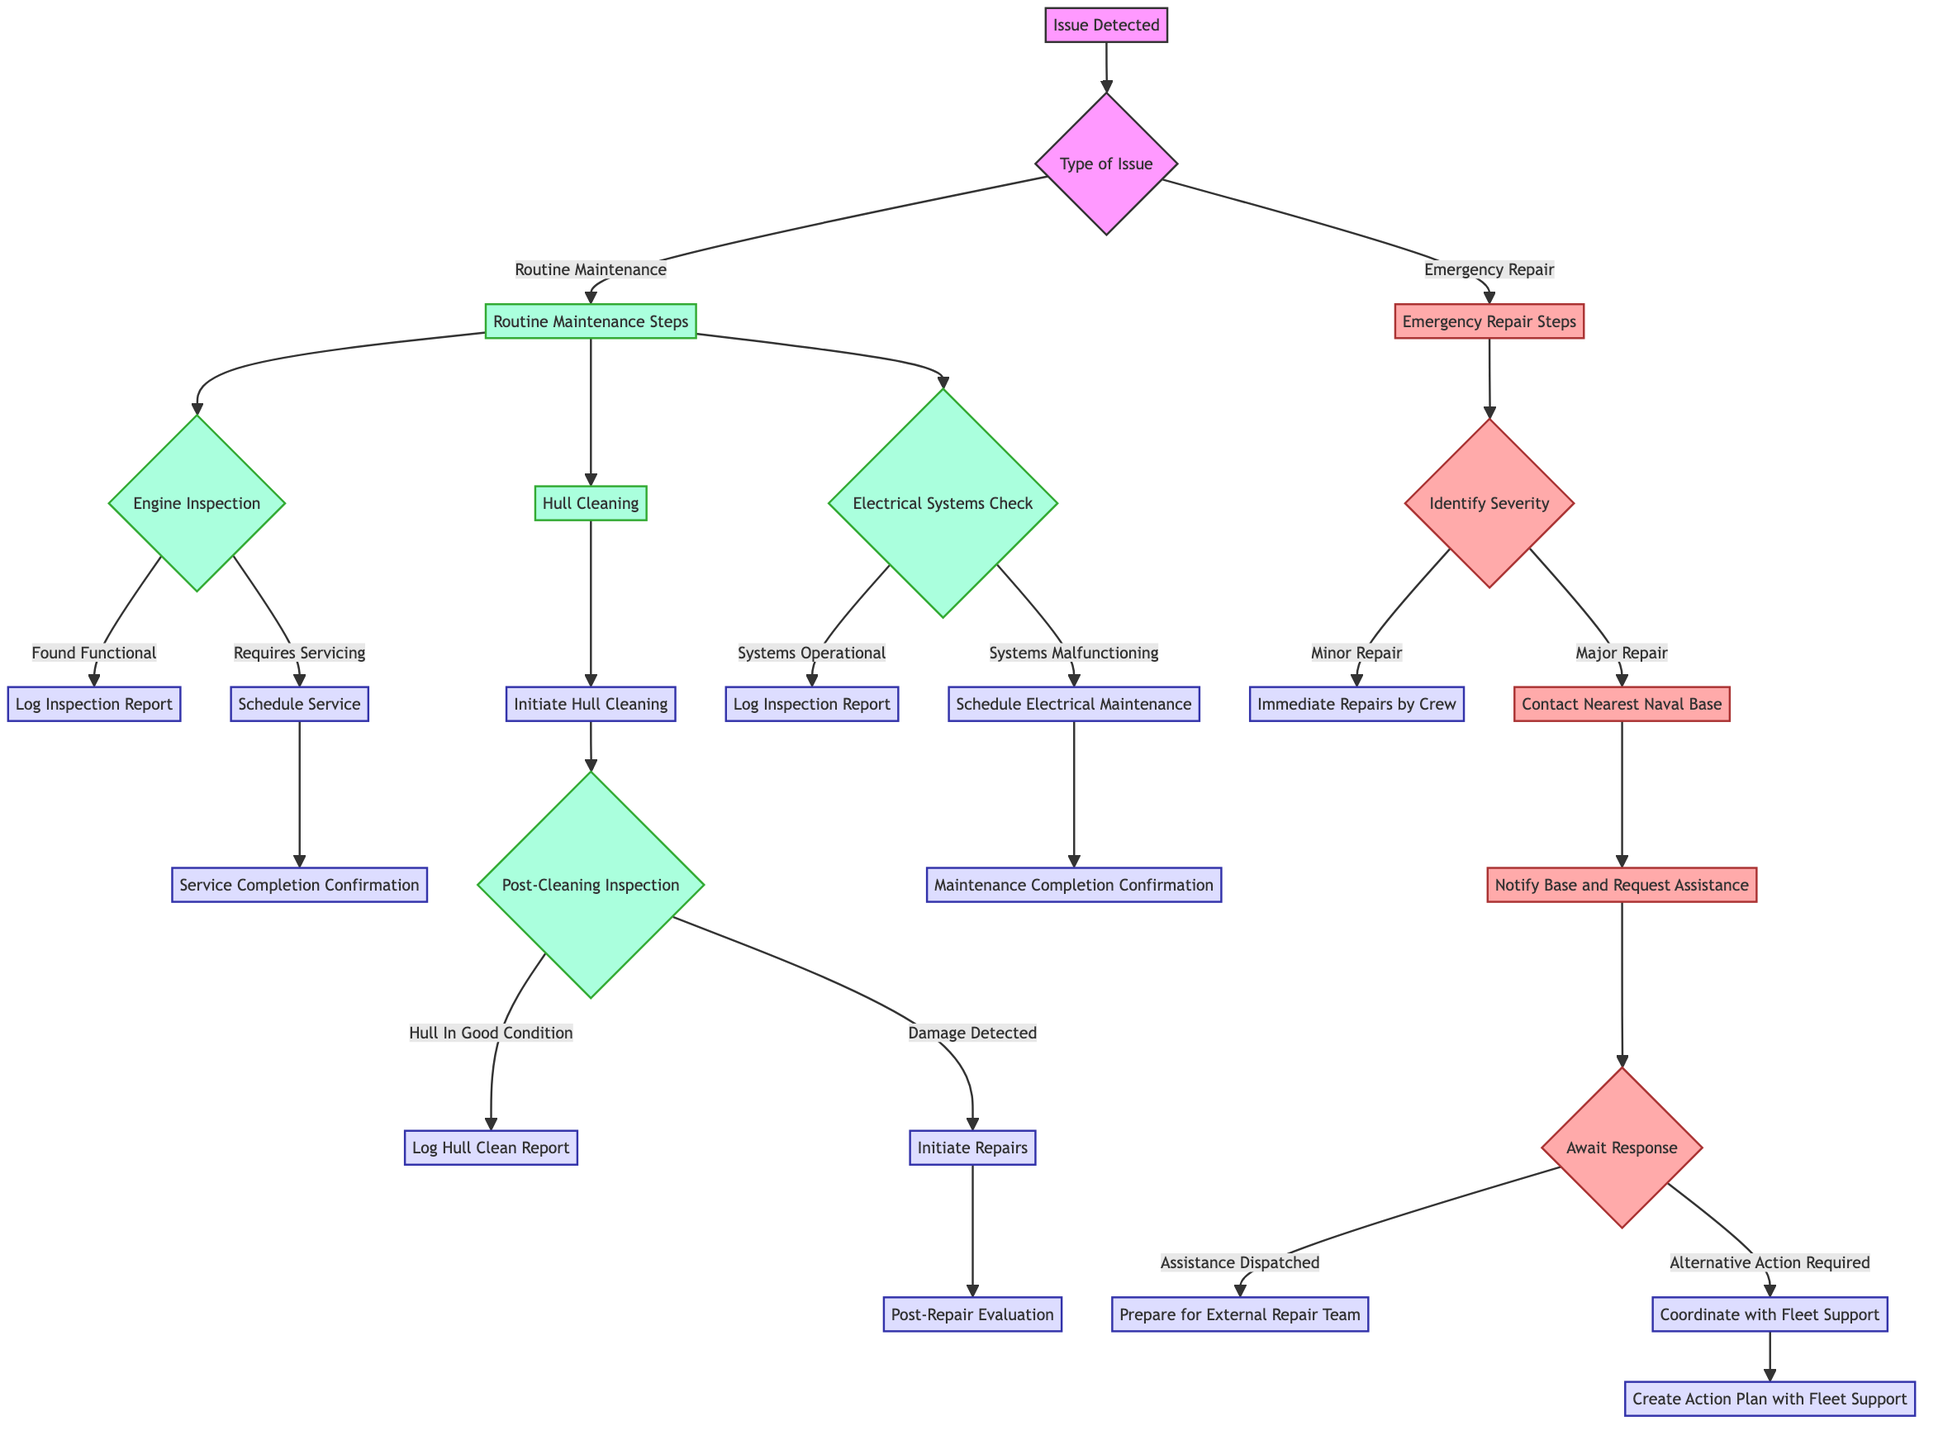What are the two main types of issues identified in the diagram? The diagram shows two main branches from the "Type of Issue" node: "Routine Maintenance" and "Emergency Repair." These are the major distinctions made for handling issues detected in ship maintenance.
Answer: Routine Maintenance, Emergency Repair How many steps are there under "Routine Maintenance Steps"? The "Routine Maintenance Steps" includes three distinct steps: Engine Inspection, Hull Cleaning, and Electrical Systems Check. Each of these branches leads to further actions or checks.
Answer: 3 What is the action taken if the engine requires servicing? If the engine requires servicing, the action specified in the diagram is to "Schedule Service," followed by "Service Completion Confirmation."
Answer: Schedule Service What happens during the Post-Cleaning Inspection if damage is detected? If damage is detected during the Post-Cleaning Inspection, the next action is to "Initiate Repairs," which proceeds to a "Post-Repair Evaluation" step. This indicates a process for evaluating repairs.
Answer: Initiate Repairs What occurs after identifying the severity of an issue in Emergency Repair Steps? After identifying the severity, if it is a Minor Repair, the action is "Immediate Repairs by Crew." If it is Major Repair, the next action is "Contact Nearest Naval Base," which indicates a more complex response is required.
Answer: Immediate Repairs by Crew, Contact Nearest Naval Base What is the next step after logging a hull clean report? Following the logging of a hull clean report, there aren't further steps mentioned in the diagram; thus, that action concludes that particular pathway.
Answer: No further steps What are the two outcomes after Awaiting Response in Emergency Repair Steps? After "Await Response," the two possible outcomes identified are "Assistance Dispatched," leading to preparation for the external repair team, and "Alternative Action Required," which leads to coordination with Fleet Support.
Answer: Assistance Dispatched, Alternative Action Required What is initiated if Electrical Systems are malfunctioning? If the Electrical Systems are found to be malfunctioning, the action that needs to be taken is to "Schedule Electrical Maintenance." This highlights the need for further immediate intervention for non-functional systems.
Answer: Schedule Electrical Maintenance 